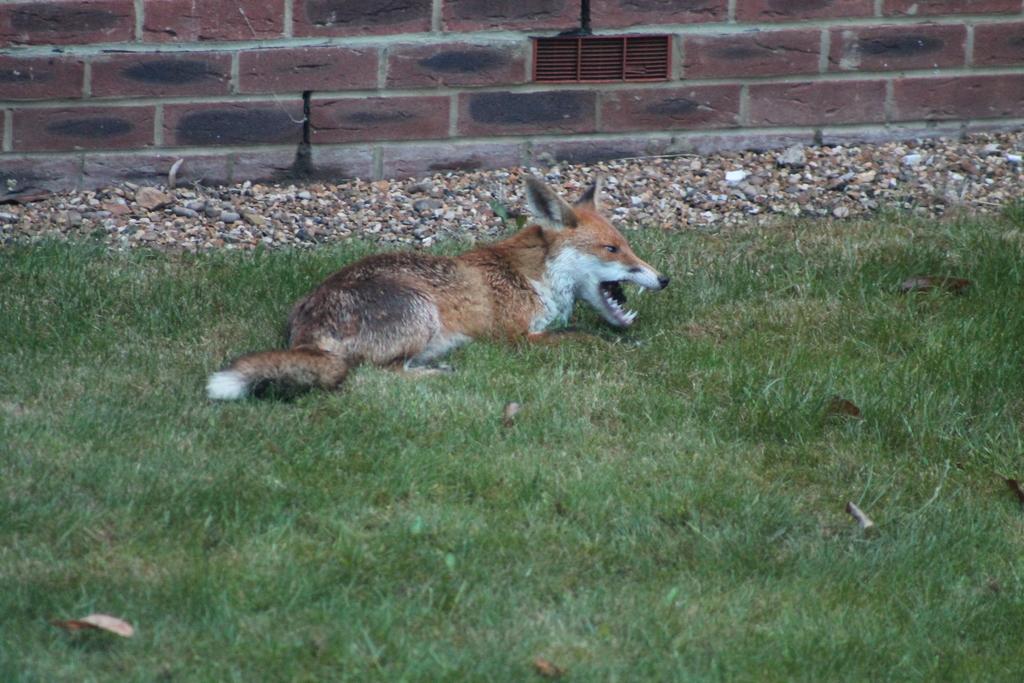In one or two sentences, can you explain what this image depicts? In the foreground of the image we can see grass. In the middle of the image we can see a dog lying on the grass and some stones. On the top of the image we can see a wall. 